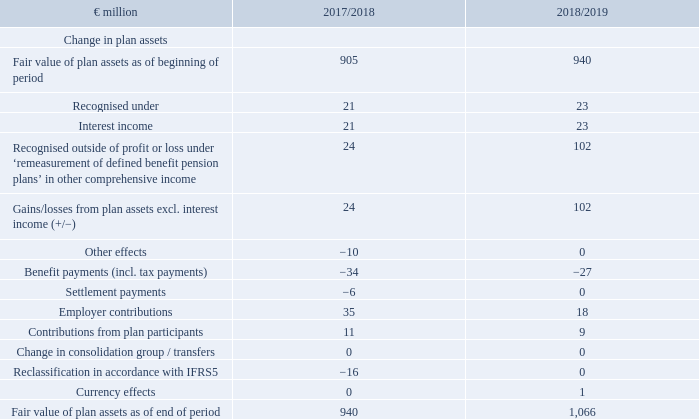The actual return on plan assets amounted to €125 million in the reporting period (2017/ 18: €45 million).
For financial year 2019/20, the company expects employer payments to external pension providers totalling approximately €18 million and employee contributions of €9 million in plan assets, with contributions in the Netherlands, Belgium and Germany accounting for the major share of this total. Expected contributions from payment contribution commitments in Germany are not included in expected payments.
The fair value of plan assets developed as follows:
At one Dutch company, plan assets exceeded the value of commitments as of the closing date. Since the company cannot draw any economic benefits from this overfunding, the balance sheet amount was reduced to €0 in line with IAS 19.64 (b).
How much did the actual return on plan assets amount to in FY2019? €125 million. What is not included in expected payments? Expected contributions from payment contribution commitments in germany. For which years was the Fair value of plan assets as of end of period calculated in? 2018, 2019. In which year was Interest income larger? 23>21
Answer: 2019. What was the change in interest income in FY2019 from FY2018?
Answer scale should be: million. 23-21
Answer: 2. What was the percentage change in interest income in FY2019 from FY2018?
Answer scale should be: percent. (23-21)/21
Answer: 9.52. 